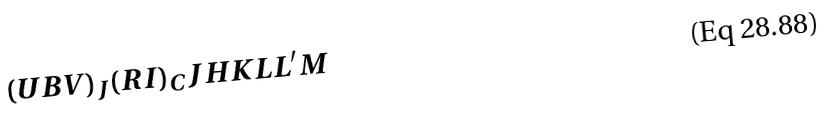<formula> <loc_0><loc_0><loc_500><loc_500>( U B V ) _ { J } ( R I ) _ { C } J H K L L ^ { \prime } M</formula> 